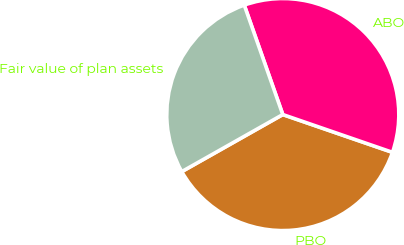<chart> <loc_0><loc_0><loc_500><loc_500><pie_chart><fcel>PBO<fcel>ABO<fcel>Fair value of plan assets<nl><fcel>36.54%<fcel>35.67%<fcel>27.8%<nl></chart> 